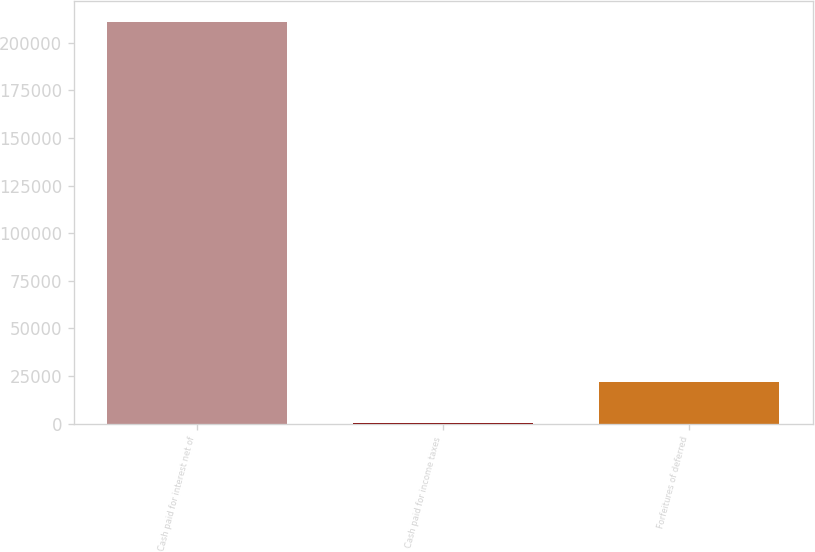<chart> <loc_0><loc_0><loc_500><loc_500><bar_chart><fcel>Cash paid for interest net of<fcel>Cash paid for income taxes<fcel>Forfeitures of deferred<nl><fcel>211064<fcel>641<fcel>21683.3<nl></chart> 